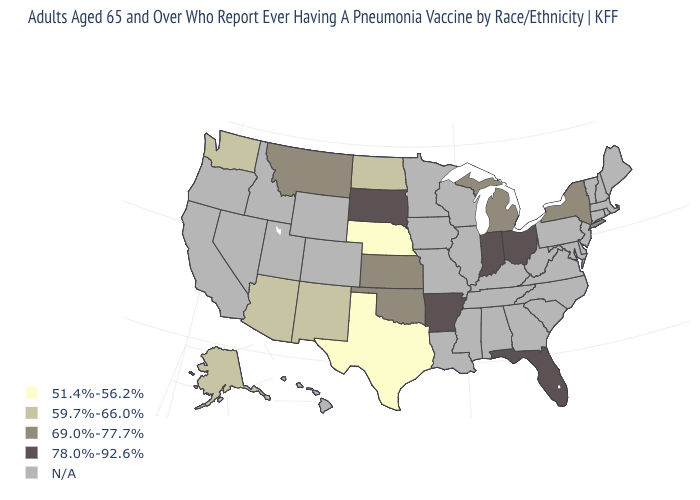Which states have the lowest value in the West?
Concise answer only. Alaska, Arizona, New Mexico, Washington. What is the value of Ohio?
Answer briefly. 78.0%-92.6%. Name the states that have a value in the range N/A?
Quick response, please. Alabama, California, Colorado, Connecticut, Delaware, Georgia, Hawaii, Idaho, Illinois, Iowa, Kentucky, Louisiana, Maine, Maryland, Massachusetts, Minnesota, Mississippi, Missouri, Nevada, New Hampshire, New Jersey, North Carolina, Oregon, Pennsylvania, Rhode Island, South Carolina, Tennessee, Utah, Vermont, Virginia, West Virginia, Wisconsin, Wyoming. Among the states that border Missouri , which have the lowest value?
Be succinct. Nebraska. Name the states that have a value in the range 59.7%-66.0%?
Keep it brief. Alaska, Arizona, New Mexico, North Dakota, Washington. What is the value of Texas?
Quick response, please. 51.4%-56.2%. Among the states that border Colorado , does Nebraska have the lowest value?
Keep it brief. Yes. What is the lowest value in the USA?
Write a very short answer. 51.4%-56.2%. Does Florida have the lowest value in the South?
Quick response, please. No. What is the value of Idaho?
Short answer required. N/A. Name the states that have a value in the range 69.0%-77.7%?
Short answer required. Kansas, Michigan, Montana, New York, Oklahoma. 